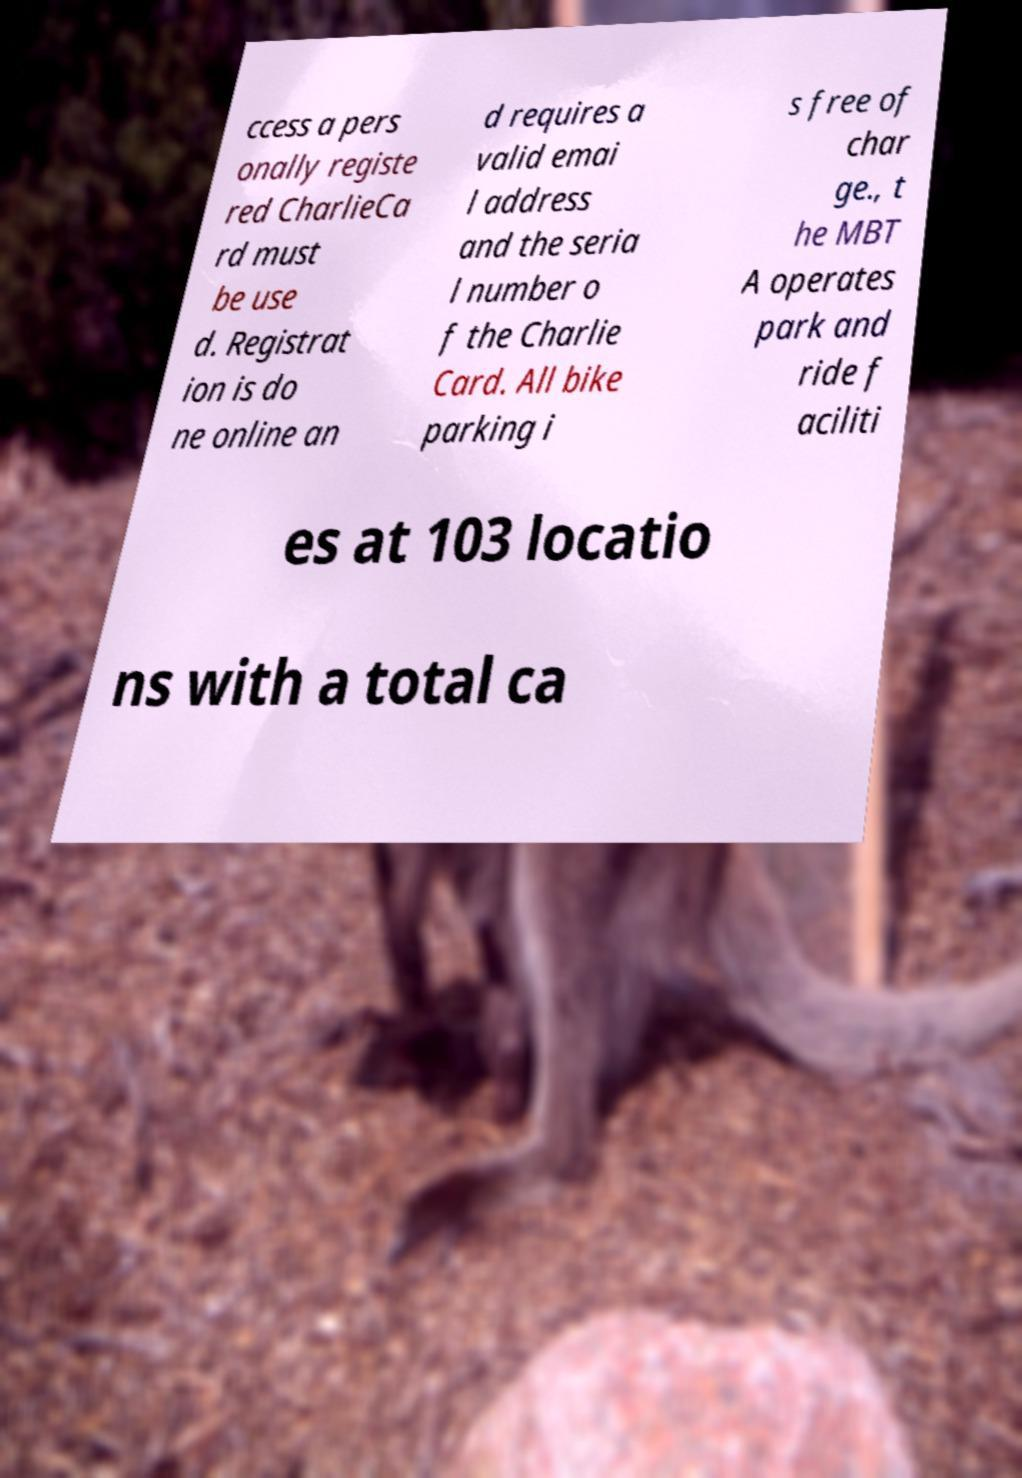Please read and relay the text visible in this image. What does it say? ccess a pers onally registe red CharlieCa rd must be use d. Registrat ion is do ne online an d requires a valid emai l address and the seria l number o f the Charlie Card. All bike parking i s free of char ge., t he MBT A operates park and ride f aciliti es at 103 locatio ns with a total ca 